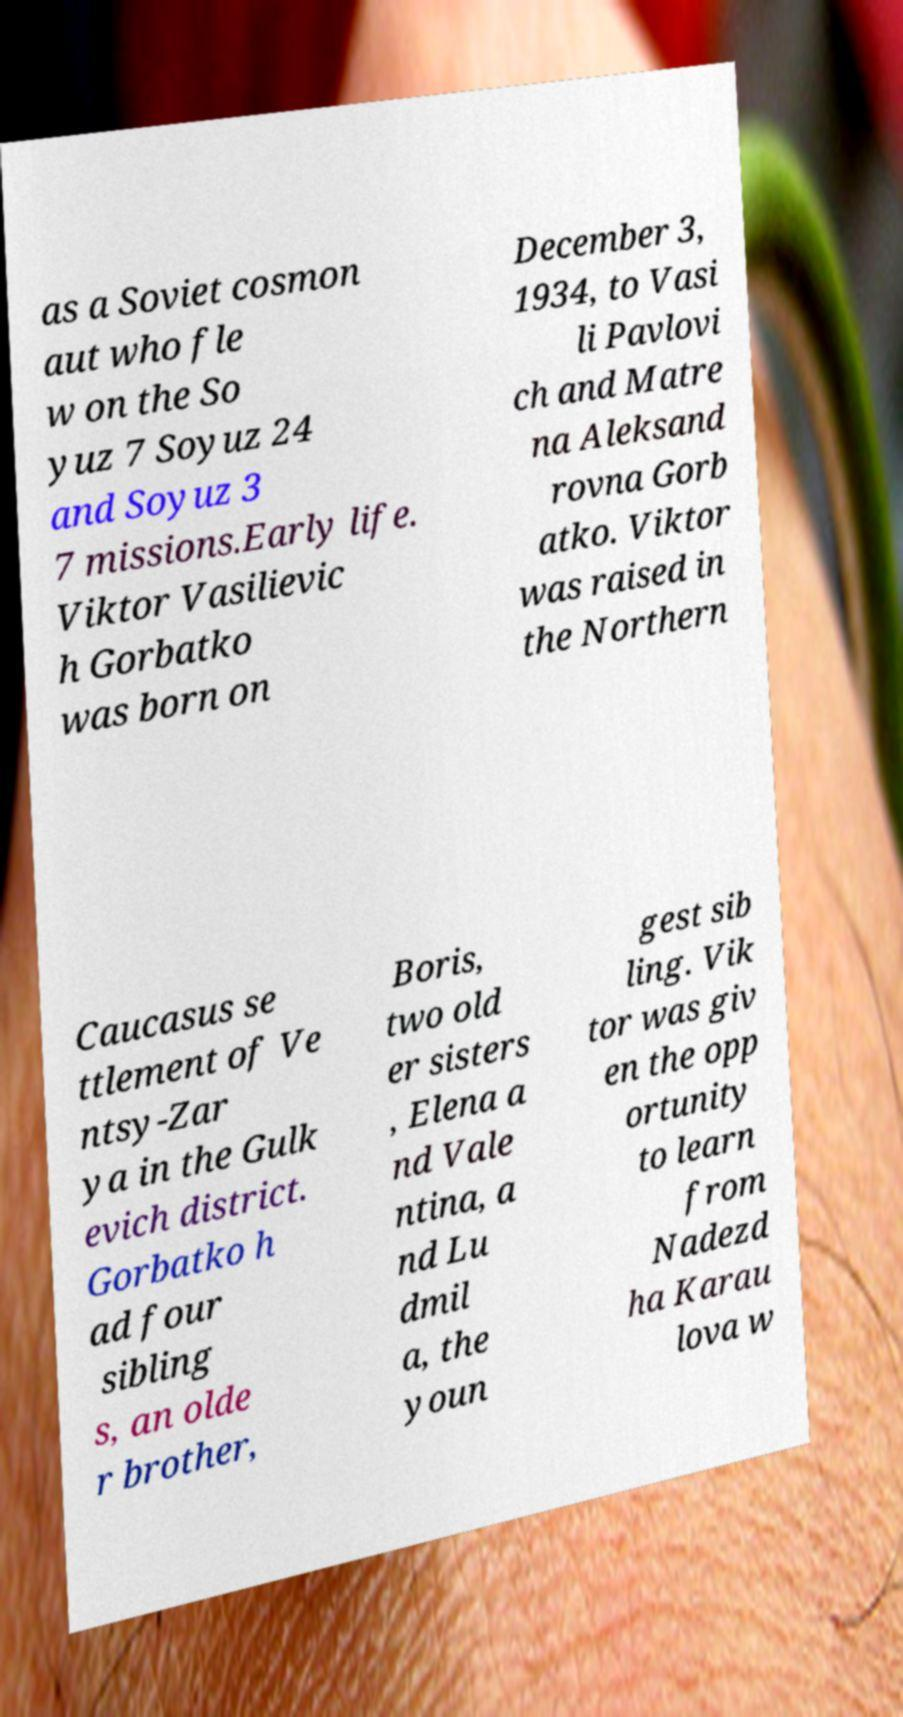Can you accurately transcribe the text from the provided image for me? as a Soviet cosmon aut who fle w on the So yuz 7 Soyuz 24 and Soyuz 3 7 missions.Early life. Viktor Vasilievic h Gorbatko was born on December 3, 1934, to Vasi li Pavlovi ch and Matre na Aleksand rovna Gorb atko. Viktor was raised in the Northern Caucasus se ttlement of Ve ntsy-Zar ya in the Gulk evich district. Gorbatko h ad four sibling s, an olde r brother, Boris, two old er sisters , Elena a nd Vale ntina, a nd Lu dmil a, the youn gest sib ling. Vik tor was giv en the opp ortunity to learn from Nadezd ha Karau lova w 